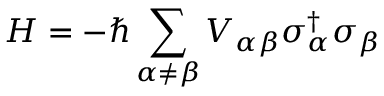<formula> <loc_0><loc_0><loc_500><loc_500>H = - \hbar { \sum } _ { \alpha \neq \beta } V _ { \alpha \beta } \sigma _ { \alpha } ^ { \dagger } \sigma _ { \beta }</formula> 